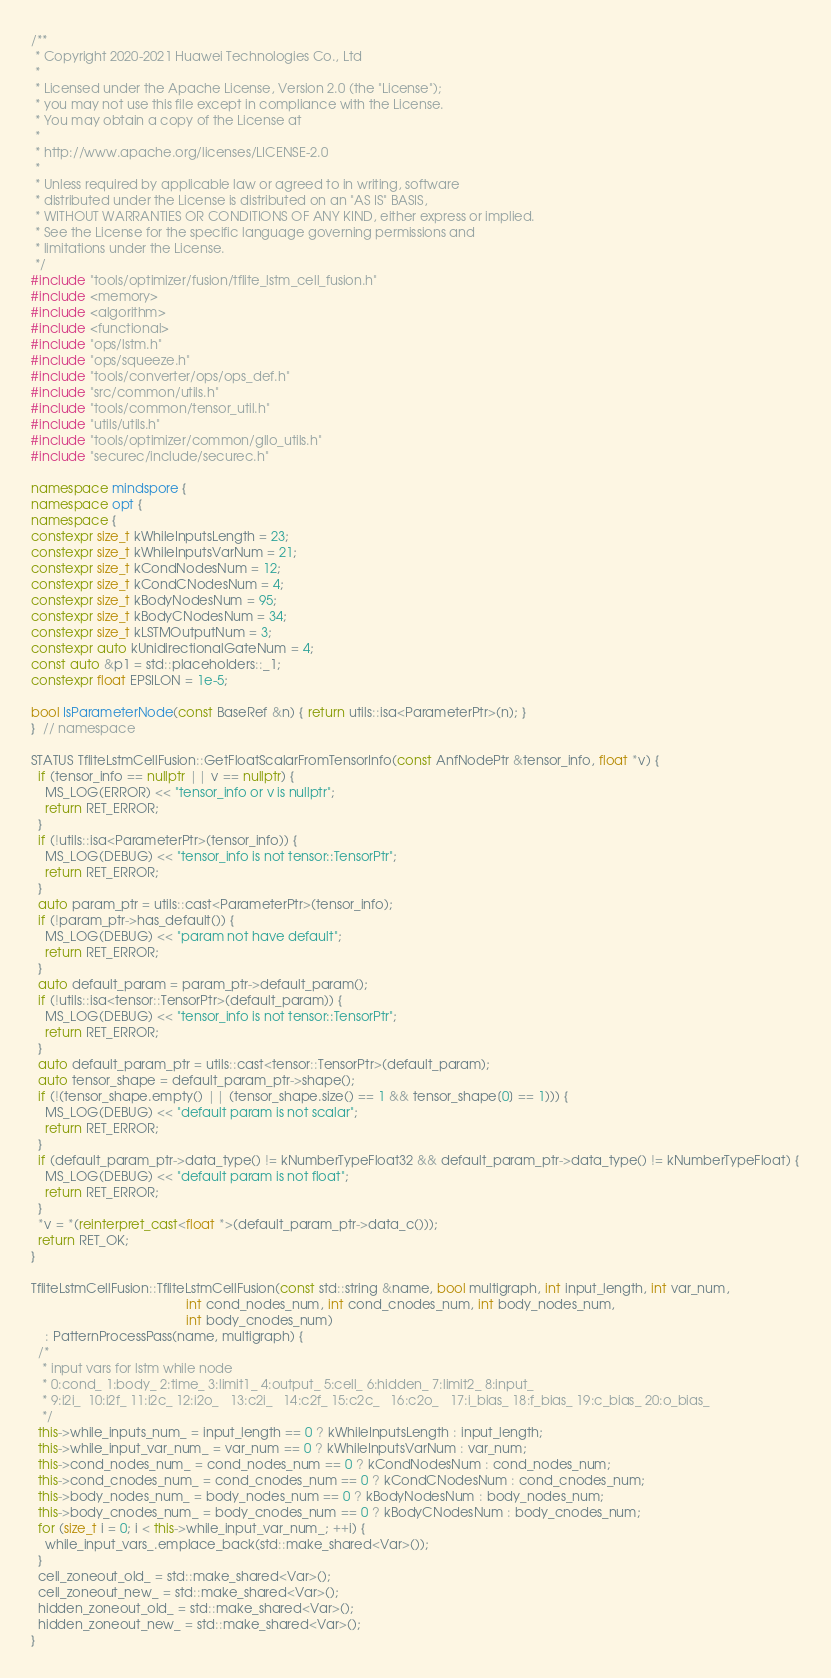Convert code to text. <code><loc_0><loc_0><loc_500><loc_500><_C++_>/**
 * Copyright 2020-2021 Huawei Technologies Co., Ltd
 *
 * Licensed under the Apache License, Version 2.0 (the "License");
 * you may not use this file except in compliance with the License.
 * You may obtain a copy of the License at
 *
 * http://www.apache.org/licenses/LICENSE-2.0
 *
 * Unless required by applicable law or agreed to in writing, software
 * distributed under the License is distributed on an "AS IS" BASIS,
 * WITHOUT WARRANTIES OR CONDITIONS OF ANY KIND, either express or implied.
 * See the License for the specific language governing permissions and
 * limitations under the License.
 */
#include "tools/optimizer/fusion/tflite_lstm_cell_fusion.h"
#include <memory>
#include <algorithm>
#include <functional>
#include "ops/lstm.h"
#include "ops/squeeze.h"
#include "tools/converter/ops/ops_def.h"
#include "src/common/utils.h"
#include "tools/common/tensor_util.h"
#include "utils/utils.h"
#include "tools/optimizer/common/gllo_utils.h"
#include "securec/include/securec.h"

namespace mindspore {
namespace opt {
namespace {
constexpr size_t kWhileInputsLength = 23;
constexpr size_t kWhileInputsVarNum = 21;
constexpr size_t kCondNodesNum = 12;
constexpr size_t kCondCNodesNum = 4;
constexpr size_t kBodyNodesNum = 95;
constexpr size_t kBodyCNodesNum = 34;
constexpr size_t kLSTMOutputNum = 3;
constexpr auto kUnidirectionalGateNum = 4;
const auto &p1 = std::placeholders::_1;
constexpr float EPSILON = 1e-5;

bool IsParameterNode(const BaseRef &n) { return utils::isa<ParameterPtr>(n); }
}  // namespace

STATUS TfliteLstmCellFusion::GetFloatScalarFromTensorInfo(const AnfNodePtr &tensor_info, float *v) {
  if (tensor_info == nullptr || v == nullptr) {
    MS_LOG(ERROR) << "tensor_info or v is nullptr";
    return RET_ERROR;
  }
  if (!utils::isa<ParameterPtr>(tensor_info)) {
    MS_LOG(DEBUG) << "tensor_info is not tensor::TensorPtr";
    return RET_ERROR;
  }
  auto param_ptr = utils::cast<ParameterPtr>(tensor_info);
  if (!param_ptr->has_default()) {
    MS_LOG(DEBUG) << "param not have default";
    return RET_ERROR;
  }
  auto default_param = param_ptr->default_param();
  if (!utils::isa<tensor::TensorPtr>(default_param)) {
    MS_LOG(DEBUG) << "tensor_info is not tensor::TensorPtr";
    return RET_ERROR;
  }
  auto default_param_ptr = utils::cast<tensor::TensorPtr>(default_param);
  auto tensor_shape = default_param_ptr->shape();
  if (!(tensor_shape.empty() || (tensor_shape.size() == 1 && tensor_shape[0] == 1))) {
    MS_LOG(DEBUG) << "default param is not scalar";
    return RET_ERROR;
  }
  if (default_param_ptr->data_type() != kNumberTypeFloat32 && default_param_ptr->data_type() != kNumberTypeFloat) {
    MS_LOG(DEBUG) << "default param is not float";
    return RET_ERROR;
  }
  *v = *(reinterpret_cast<float *>(default_param_ptr->data_c()));
  return RET_OK;
}

TfliteLstmCellFusion::TfliteLstmCellFusion(const std::string &name, bool multigraph, int input_length, int var_num,
                                           int cond_nodes_num, int cond_cnodes_num, int body_nodes_num,
                                           int body_cnodes_num)
    : PatternProcessPass(name, multigraph) {
  /*
   * input vars for lstm while node
   * 0:cond_ 1:body_ 2:time_ 3:limit1_ 4:output_ 5:cell_ 6:hidden_ 7:limit2_ 8:input_
   * 9:i2i_  10:i2f_ 11:i2c_ 12:i2o_   13:c2i_   14:c2f_ 15:c2c_   16:c2o_   17:i_bias_ 18:f_bias_ 19:c_bias_ 20:o_bias_
   */
  this->while_inputs_num_ = input_length == 0 ? kWhileInputsLength : input_length;
  this->while_input_var_num_ = var_num == 0 ? kWhileInputsVarNum : var_num;
  this->cond_nodes_num_ = cond_nodes_num == 0 ? kCondNodesNum : cond_nodes_num;
  this->cond_cnodes_num_ = cond_cnodes_num == 0 ? kCondCNodesNum : cond_cnodes_num;
  this->body_nodes_num_ = body_nodes_num == 0 ? kBodyNodesNum : body_nodes_num;
  this->body_cnodes_num_ = body_cnodes_num == 0 ? kBodyCNodesNum : body_cnodes_num;
  for (size_t i = 0; i < this->while_input_var_num_; ++i) {
    while_input_vars_.emplace_back(std::make_shared<Var>());
  }
  cell_zoneout_old_ = std::make_shared<Var>();
  cell_zoneout_new_ = std::make_shared<Var>();
  hidden_zoneout_old_ = std::make_shared<Var>();
  hidden_zoneout_new_ = std::make_shared<Var>();
}
</code> 